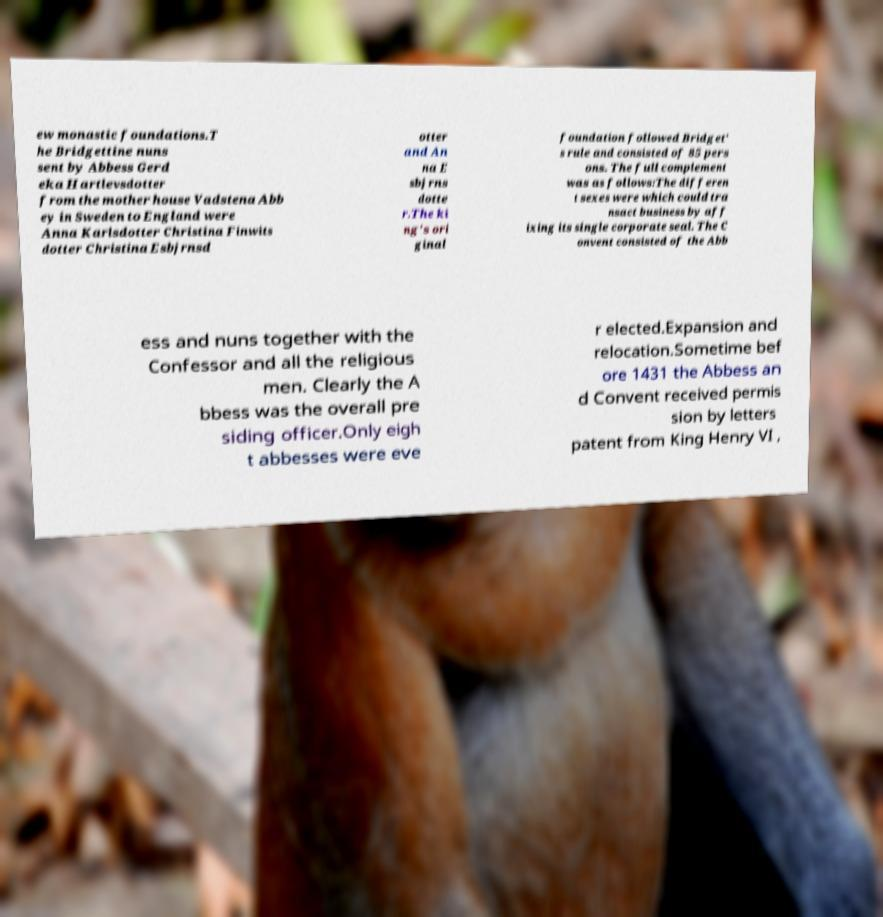Please identify and transcribe the text found in this image. ew monastic foundations.T he Bridgettine nuns sent by Abbess Gerd eka Hartlevsdotter from the mother house Vadstena Abb ey in Sweden to England were Anna Karlsdotter Christina Finwits dotter Christina Esbjrnsd otter and An na E sbjrns dotte r.The ki ng's ori ginal foundation followed Bridget' s rule and consisted of 85 pers ons. The full complement was as follows:The differen t sexes were which could tra nsact business by aff ixing its single corporate seal. The C onvent consisted of the Abb ess and nuns together with the Confessor and all the religious men. Clearly the A bbess was the overall pre siding officer.Only eigh t abbesses were eve r elected.Expansion and relocation.Sometime bef ore 1431 the Abbess an d Convent received permis sion by letters patent from King Henry VI , 